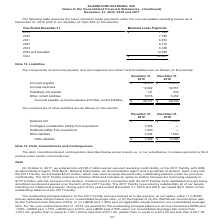From Alarmcom Holdings's financial document, Which years does the table provide information for the components of accounts payable, accrued expenses and other current liabilities? The document shows two values: 2019 and 2018. From the document: "December 31, 2019 December 31, 2018 Accounts payable $ 32,878 $ 20,214 Accrued expenses 10,092 34,557 Subsidiary unit December 31, 2019 December 31, 2..." Also, How much were other liabilities in 2019? According to the financial document, 3,244 (in thousands). The relevant text states: "ility from acquisitions 1,650 — Other liabilities 3,244 1,650 Other liabilities $ 7,489 $ 13,306..." Also, How much was the deferred rent in 2018? According to the financial document, 11,656 (in thousands). The relevant text states: "er 31, 2019 December 31, 2018 Deferred rent $ — $ 11,656 Contingent consideration liability from acquisitions 2,595 — Holdback liability from acquisitions 1..." Also, can you calculate: What was the change in Other liabilities between 2018 and 2019? Based on the calculation: 3,244-1,650, the result is 1594 (in thousands). This is based on the information: "ions 2,595 — Holdback liability from acquisitions 1,650 — Other liabilities 3,244 1,650 Other liabilities $ 7,489 $ 13,306 ility from acquisitions 1,650 — Other liabilities 3,244 1,650 Other liabiliti..." The key data points involved are: 1,650, 3,244. Also, How many liabilities in 2019 exceeded $2,000 thousand? Counting the relevant items in the document: Contingent consideration liability from acquisitions, Other liabilities, I find 2 instances. The key data points involved are: Contingent consideration liability from acquisitions, Other liabilities. Also, can you calculate: What was the percentage change in total other liabilities between 2018 and 2019? To answer this question, I need to perform calculations using the financial data. The calculation is: (7,489-13,306)/13,306, which equals -43.72 (percentage). This is based on the information: "abilities 3,244 1,650 Other liabilities $ 7,489 $ 13,306 Other liabilities 3,244 1,650 Other liabilities $ 7,489 $ 13,306..." The key data points involved are: 13,306, 7,489. 